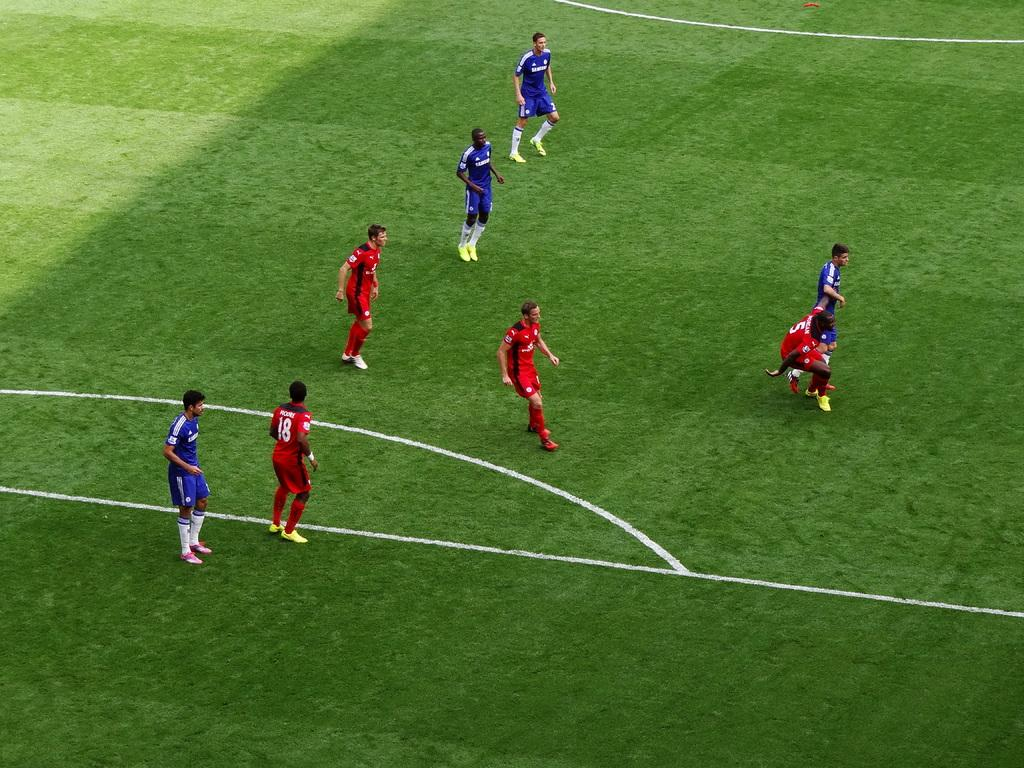<image>
Present a compact description of the photo's key features. the number 18 is on the back of a jersey 